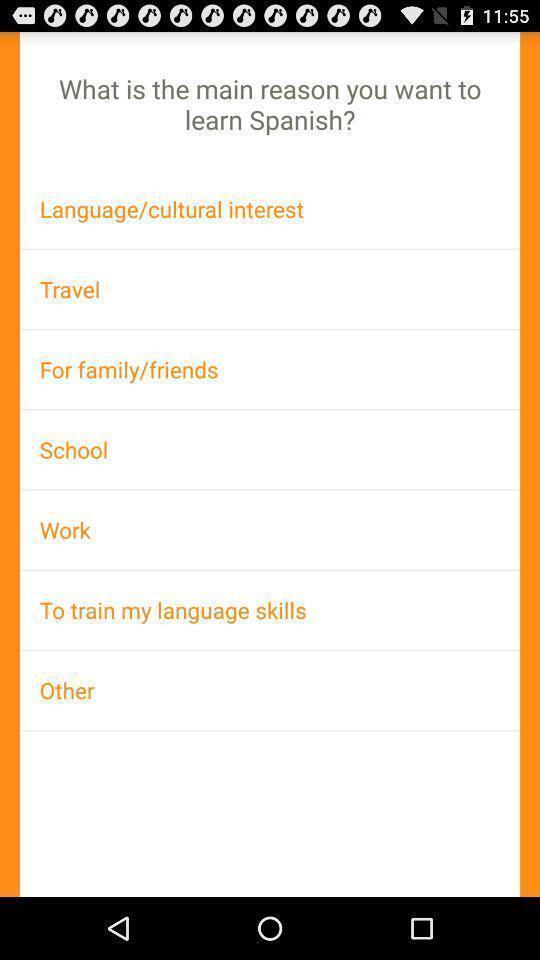Provide a textual representation of this image. Page displaying the list of reasons to learn a language. 